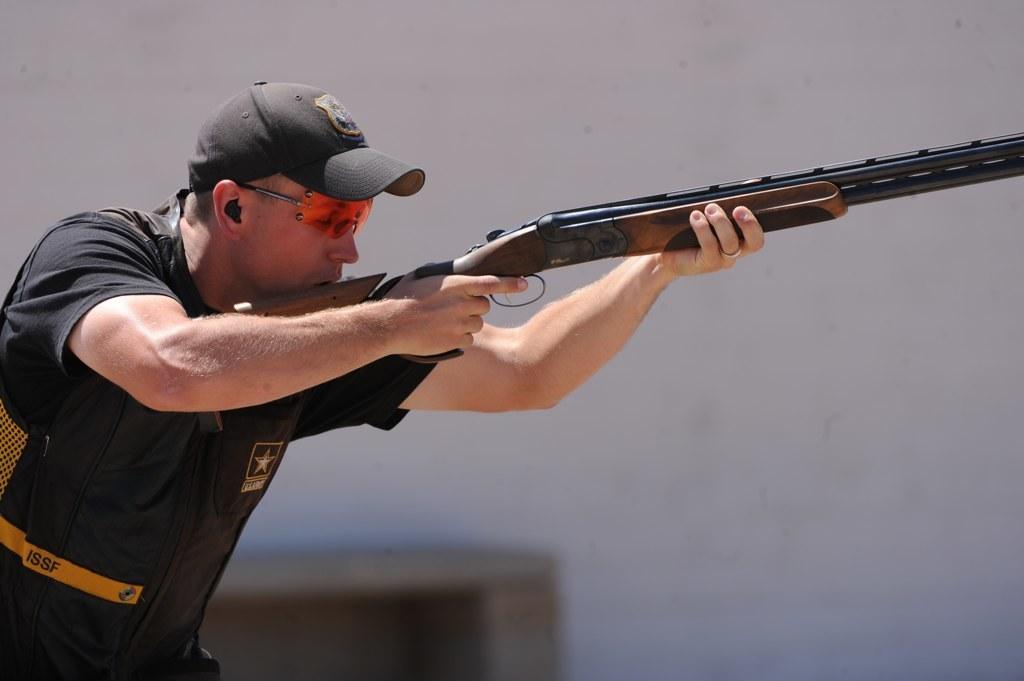Describe this image in one or two sentences. In this image there is a man standing towards the left of the image, he is wearing a cap, he is wearing goggles, he is holding a gun, there is an object towards the bottom of the image, at the background of the image there is the wall. 